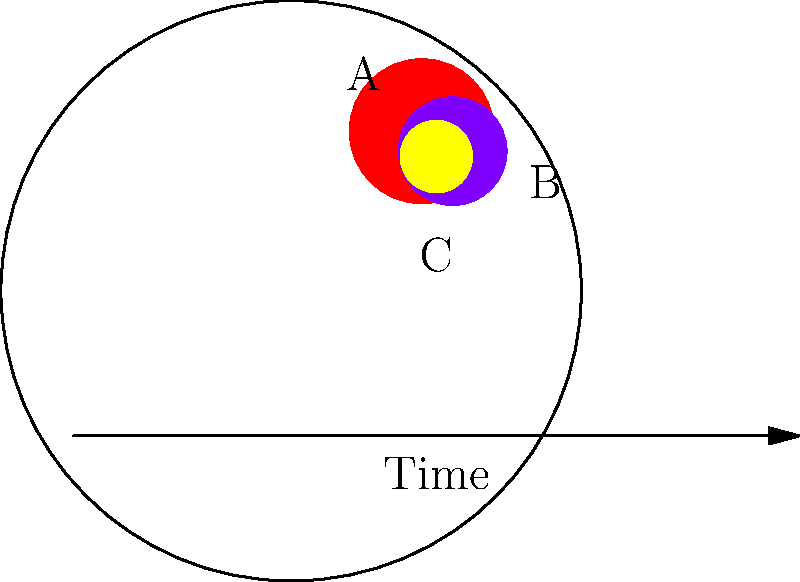In the brain diagram above, which area represents a Transient Ischemic Attack (TIA), often referred to as a "mini-stroke"? To answer this question, let's analyze the diagram and understand the characteristics of different stroke types:

1. Area A (red): This larger affected area likely represents an ischemic stroke, which occurs when a blood clot blocks a blood vessel in the brain.

2. Area B (purple): This area with a darker color might represent a hemorrhagic stroke, which happens when a blood vessel in the brain ruptures and bleeds into the surrounding tissue.

3. Area C (yellow): This smaller, lighter-colored area represents a Transient Ischemic Attack (TIA) or "mini-stroke."

TIAs are characterized by:
- Temporary blockage of blood flow to the brain
- Symptoms that typically last only a few minutes to hours
- No permanent damage to brain tissue

The diagram shows Area C as smaller and lighter in color, indicating its temporary and less severe nature compared to the other stroke types. Additionally, the arrow labeled "Time" at the bottom of the diagram suggests that TIAs have a shorter duration than other stroke types.

Given these characteristics, Area C best represents a Transient Ischemic Attack (TIA).
Answer: C 